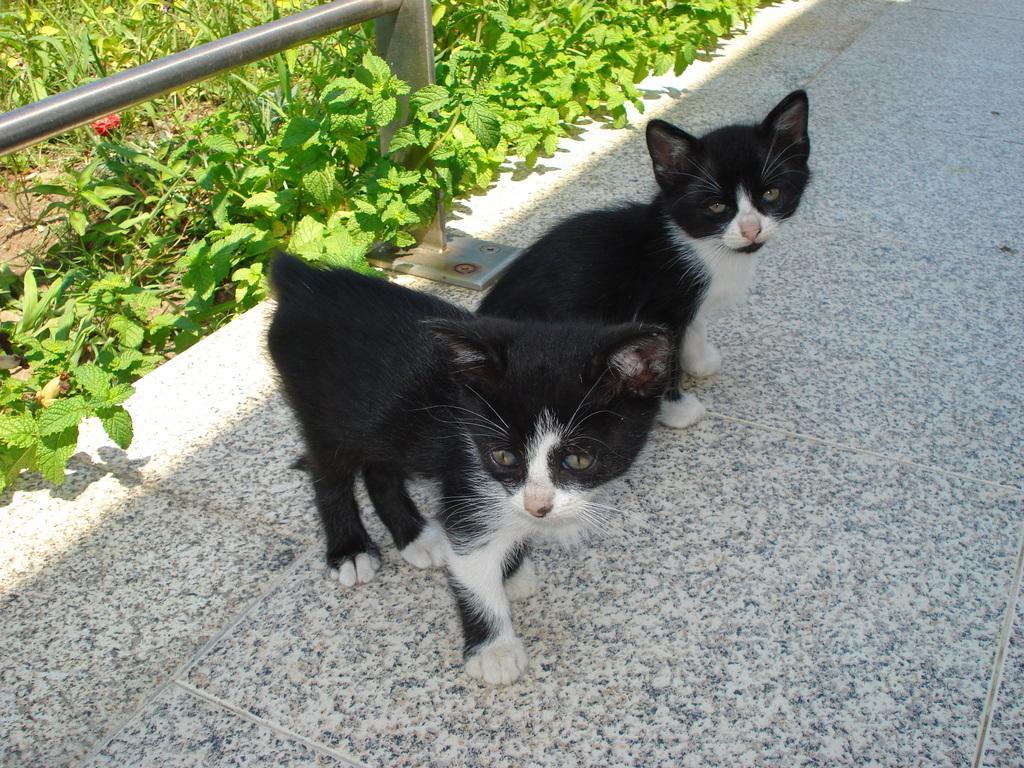Could you give a brief overview of what you see in this image? On this tile surface there are kittens. These kittens are in black and white color. Left side corner of the image we can see rods and plants. 